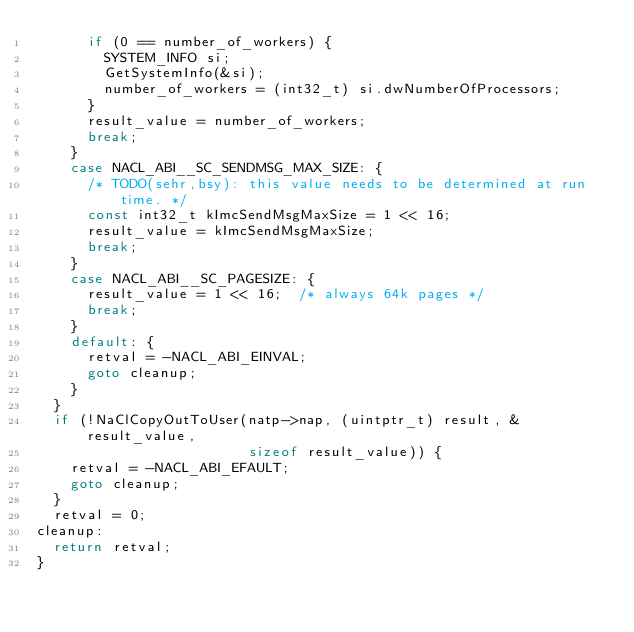Convert code to text. <code><loc_0><loc_0><loc_500><loc_500><_C_>      if (0 == number_of_workers) {
        SYSTEM_INFO si;
        GetSystemInfo(&si);
        number_of_workers = (int32_t) si.dwNumberOfProcessors;
      }
      result_value = number_of_workers;
      break;
    }
    case NACL_ABI__SC_SENDMSG_MAX_SIZE: {
      /* TODO(sehr,bsy): this value needs to be determined at run time. */
      const int32_t kImcSendMsgMaxSize = 1 << 16;
      result_value = kImcSendMsgMaxSize;
      break;
    }
    case NACL_ABI__SC_PAGESIZE: {
      result_value = 1 << 16;  /* always 64k pages */
      break;
    }
    default: {
      retval = -NACL_ABI_EINVAL;
      goto cleanup;
    }
  }
  if (!NaClCopyOutToUser(natp->nap, (uintptr_t) result, &result_value,
                         sizeof result_value)) {
    retval = -NACL_ABI_EFAULT;
    goto cleanup;
  }
  retval = 0;
cleanup:
  return retval;
}
</code> 